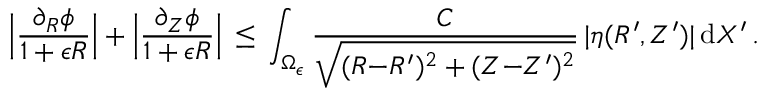Convert formula to latex. <formula><loc_0><loc_0><loc_500><loc_500>\left | \frac { \partial _ { R } \phi } { 1 + \epsilon R } \right | + \left | \frac { \partial _ { Z } \phi } { 1 + \epsilon R } \right | \, \leq \, \int _ { \Omega _ { \epsilon } } \frac { C } { \sqrt { ( R { - } R ^ { \prime } ) ^ { 2 } + ( Z { - } Z ^ { \prime } ) ^ { 2 } } } \, | \eta ( R ^ { \prime } , Z ^ { \prime } ) | \, d X ^ { \prime } \, .</formula> 